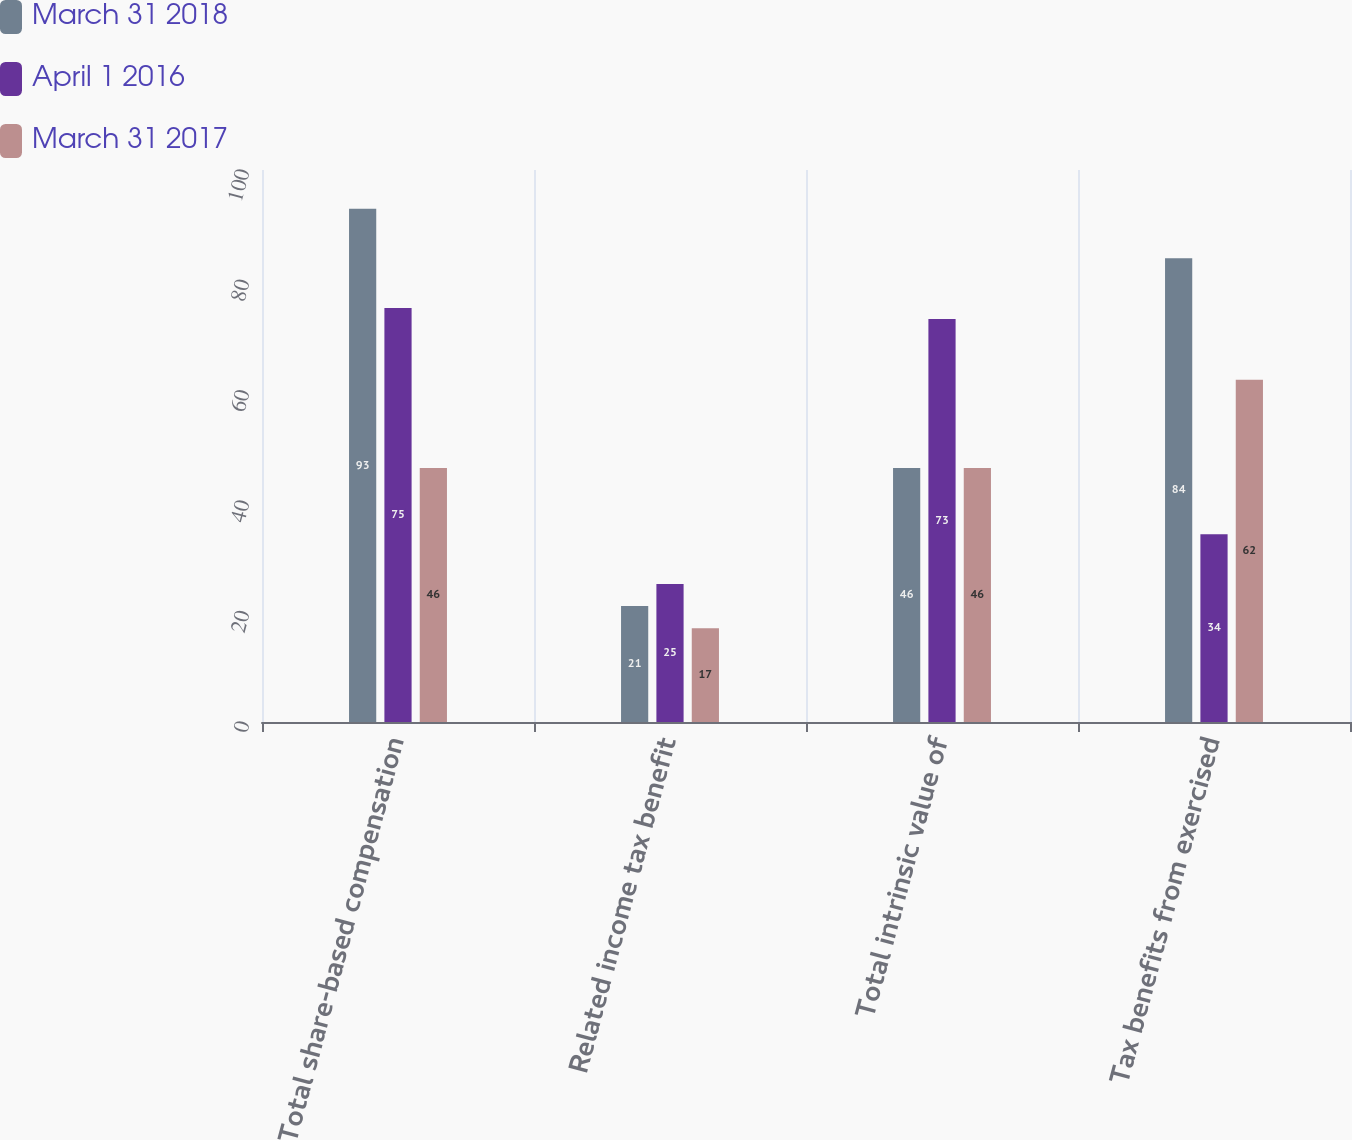Convert chart to OTSL. <chart><loc_0><loc_0><loc_500><loc_500><stacked_bar_chart><ecel><fcel>Total share-based compensation<fcel>Related income tax benefit<fcel>Total intrinsic value of<fcel>Tax benefits from exercised<nl><fcel>March 31 2018<fcel>93<fcel>21<fcel>46<fcel>84<nl><fcel>April 1 2016<fcel>75<fcel>25<fcel>73<fcel>34<nl><fcel>March 31 2017<fcel>46<fcel>17<fcel>46<fcel>62<nl></chart> 